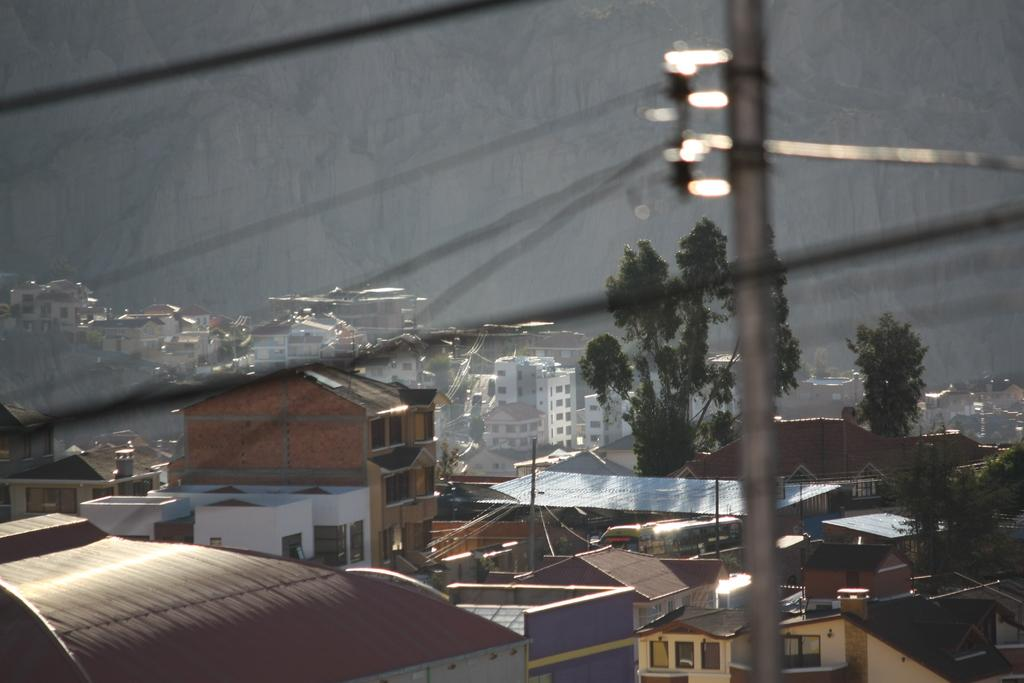What type of structures can be seen in the image? There are buildings in the image. What else is present in the image besides the buildings? There are poles and wires in the image. How many icicles are hanging from the buildings in the image? There are no icicles present in the image. What time of day is depicted in the image, as indicated by the hour on a clock tower? There is no clock tower or indication of time in the image. 